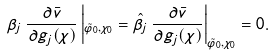Convert formula to latex. <formula><loc_0><loc_0><loc_500><loc_500>\beta _ { j } \, \frac { \partial \bar { v } } { \partial g _ { j } ( \chi ) } \left | _ { \tilde { \varphi } _ { 0 } , \chi _ { 0 } } = \hat { \beta } _ { j } \, \frac { \partial \bar { v } } { \partial g _ { j } ( \chi ) } \right | _ { \tilde { \varphi } _ { 0 } , \chi _ { 0 } } = 0 .</formula> 